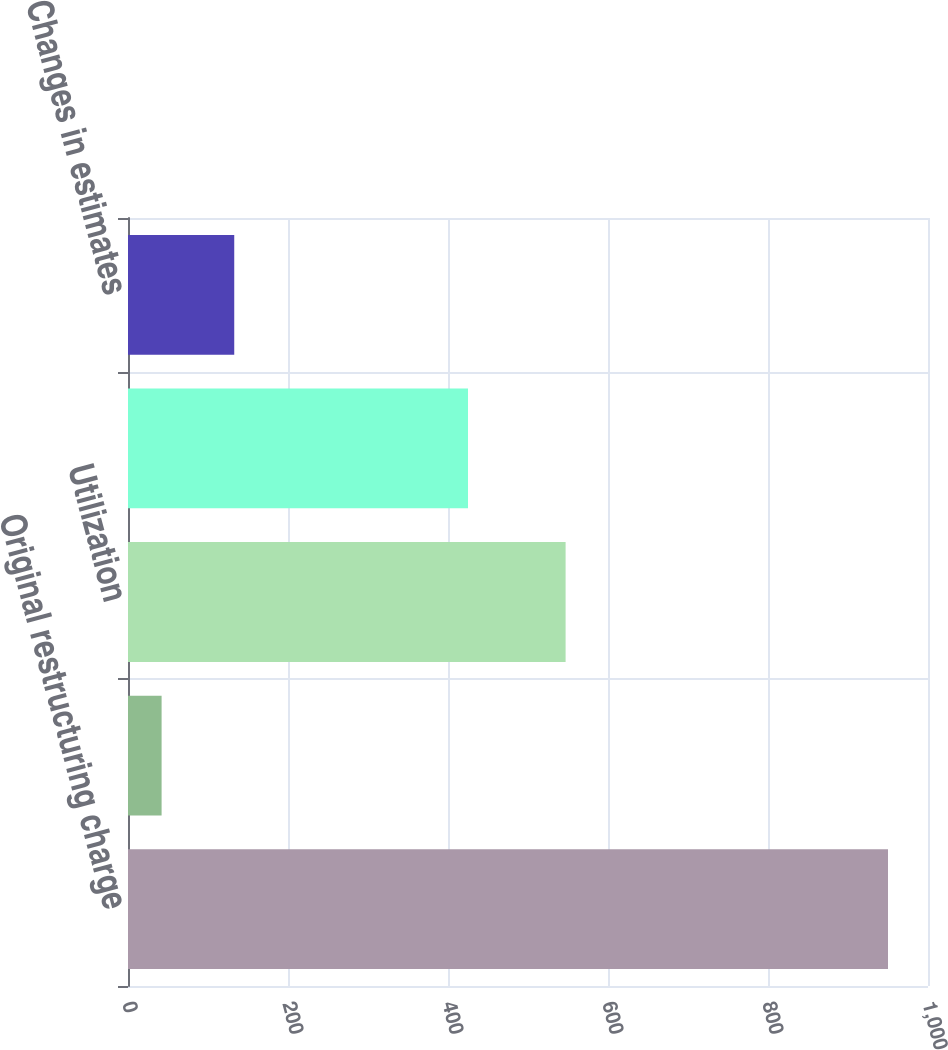<chart> <loc_0><loc_0><loc_500><loc_500><bar_chart><fcel>Original restructuring charge<fcel>Additional charge<fcel>Utilization<fcel>Balance at December 31 2007<fcel>Changes in estimates<nl><fcel>950<fcel>42<fcel>547<fcel>425<fcel>132.8<nl></chart> 